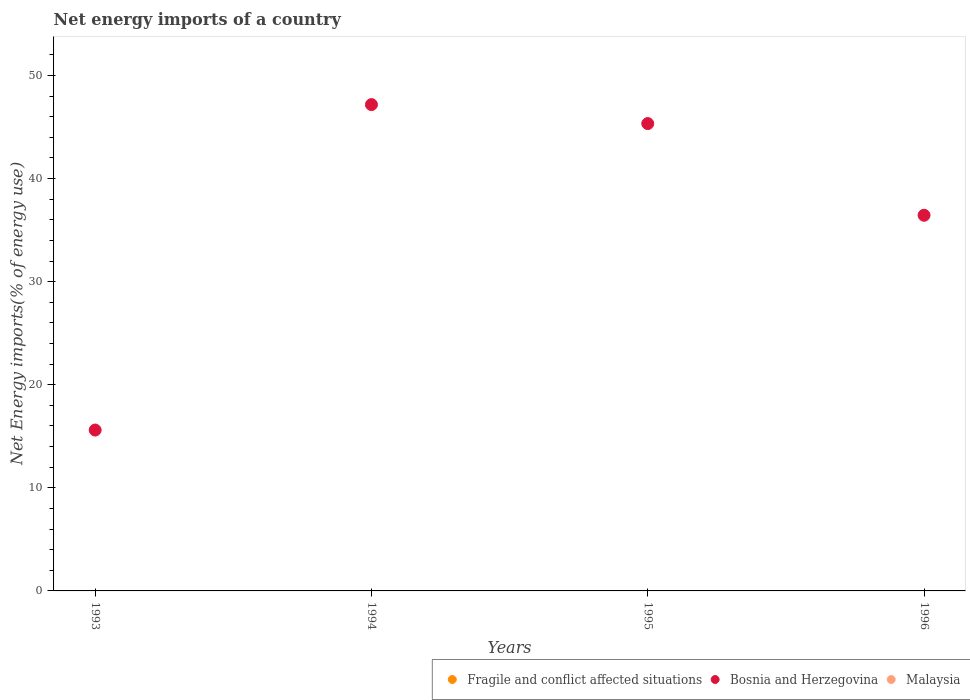How many different coloured dotlines are there?
Provide a succinct answer. 1. Is the number of dotlines equal to the number of legend labels?
Your answer should be compact. No. Across all years, what is the maximum net energy imports in Bosnia and Herzegovina?
Ensure brevity in your answer.  47.17. Across all years, what is the minimum net energy imports in Fragile and conflict affected situations?
Provide a short and direct response. 0. What is the difference between the net energy imports in Bosnia and Herzegovina in 1994 and that in 1996?
Ensure brevity in your answer.  10.73. What is the difference between the net energy imports in Fragile and conflict affected situations in 1993 and the net energy imports in Malaysia in 1996?
Make the answer very short. 0. What is the average net energy imports in Bosnia and Herzegovina per year?
Your answer should be compact. 36.14. In how many years, is the net energy imports in Fragile and conflict affected situations greater than 16 %?
Your response must be concise. 0. What is the ratio of the net energy imports in Bosnia and Herzegovina in 1995 to that in 1996?
Offer a very short reply. 1.24. What is the difference between the highest and the second highest net energy imports in Bosnia and Herzegovina?
Offer a terse response. 1.84. What is the difference between the highest and the lowest net energy imports in Bosnia and Herzegovina?
Ensure brevity in your answer.  31.57. Is the sum of the net energy imports in Bosnia and Herzegovina in 1995 and 1996 greater than the maximum net energy imports in Malaysia across all years?
Your answer should be very brief. Yes. Does the net energy imports in Malaysia monotonically increase over the years?
Provide a succinct answer. No. Is the net energy imports in Malaysia strictly greater than the net energy imports in Fragile and conflict affected situations over the years?
Your answer should be compact. No. Is the net energy imports in Bosnia and Herzegovina strictly less than the net energy imports in Malaysia over the years?
Offer a very short reply. No. Are the values on the major ticks of Y-axis written in scientific E-notation?
Provide a succinct answer. No. Does the graph contain any zero values?
Your answer should be compact. Yes. Does the graph contain grids?
Make the answer very short. No. Where does the legend appear in the graph?
Provide a succinct answer. Bottom right. What is the title of the graph?
Give a very brief answer. Net energy imports of a country. Does "Turkey" appear as one of the legend labels in the graph?
Offer a terse response. No. What is the label or title of the X-axis?
Your response must be concise. Years. What is the label or title of the Y-axis?
Ensure brevity in your answer.  Net Energy imports(% of energy use). What is the Net Energy imports(% of energy use) of Bosnia and Herzegovina in 1993?
Provide a succinct answer. 15.6. What is the Net Energy imports(% of energy use) in Fragile and conflict affected situations in 1994?
Give a very brief answer. 0. What is the Net Energy imports(% of energy use) of Bosnia and Herzegovina in 1994?
Give a very brief answer. 47.17. What is the Net Energy imports(% of energy use) in Fragile and conflict affected situations in 1995?
Provide a succinct answer. 0. What is the Net Energy imports(% of energy use) of Bosnia and Herzegovina in 1995?
Offer a terse response. 45.33. What is the Net Energy imports(% of energy use) of Malaysia in 1995?
Provide a succinct answer. 0. What is the Net Energy imports(% of energy use) of Bosnia and Herzegovina in 1996?
Offer a terse response. 36.44. What is the Net Energy imports(% of energy use) in Malaysia in 1996?
Ensure brevity in your answer.  0. Across all years, what is the maximum Net Energy imports(% of energy use) in Bosnia and Herzegovina?
Keep it short and to the point. 47.17. Across all years, what is the minimum Net Energy imports(% of energy use) of Bosnia and Herzegovina?
Keep it short and to the point. 15.6. What is the total Net Energy imports(% of energy use) in Fragile and conflict affected situations in the graph?
Your answer should be compact. 0. What is the total Net Energy imports(% of energy use) of Bosnia and Herzegovina in the graph?
Keep it short and to the point. 144.54. What is the difference between the Net Energy imports(% of energy use) in Bosnia and Herzegovina in 1993 and that in 1994?
Give a very brief answer. -31.57. What is the difference between the Net Energy imports(% of energy use) in Bosnia and Herzegovina in 1993 and that in 1995?
Your answer should be compact. -29.73. What is the difference between the Net Energy imports(% of energy use) of Bosnia and Herzegovina in 1993 and that in 1996?
Your response must be concise. -20.83. What is the difference between the Net Energy imports(% of energy use) in Bosnia and Herzegovina in 1994 and that in 1995?
Your answer should be compact. 1.84. What is the difference between the Net Energy imports(% of energy use) in Bosnia and Herzegovina in 1994 and that in 1996?
Your answer should be very brief. 10.73. What is the difference between the Net Energy imports(% of energy use) in Bosnia and Herzegovina in 1995 and that in 1996?
Keep it short and to the point. 8.89. What is the average Net Energy imports(% of energy use) of Bosnia and Herzegovina per year?
Offer a terse response. 36.14. What is the average Net Energy imports(% of energy use) in Malaysia per year?
Ensure brevity in your answer.  0. What is the ratio of the Net Energy imports(% of energy use) of Bosnia and Herzegovina in 1993 to that in 1994?
Offer a terse response. 0.33. What is the ratio of the Net Energy imports(% of energy use) in Bosnia and Herzegovina in 1993 to that in 1995?
Give a very brief answer. 0.34. What is the ratio of the Net Energy imports(% of energy use) of Bosnia and Herzegovina in 1993 to that in 1996?
Keep it short and to the point. 0.43. What is the ratio of the Net Energy imports(% of energy use) of Bosnia and Herzegovina in 1994 to that in 1995?
Offer a terse response. 1.04. What is the ratio of the Net Energy imports(% of energy use) of Bosnia and Herzegovina in 1994 to that in 1996?
Give a very brief answer. 1.29. What is the ratio of the Net Energy imports(% of energy use) of Bosnia and Herzegovina in 1995 to that in 1996?
Make the answer very short. 1.24. What is the difference between the highest and the second highest Net Energy imports(% of energy use) of Bosnia and Herzegovina?
Provide a short and direct response. 1.84. What is the difference between the highest and the lowest Net Energy imports(% of energy use) in Bosnia and Herzegovina?
Your response must be concise. 31.57. 